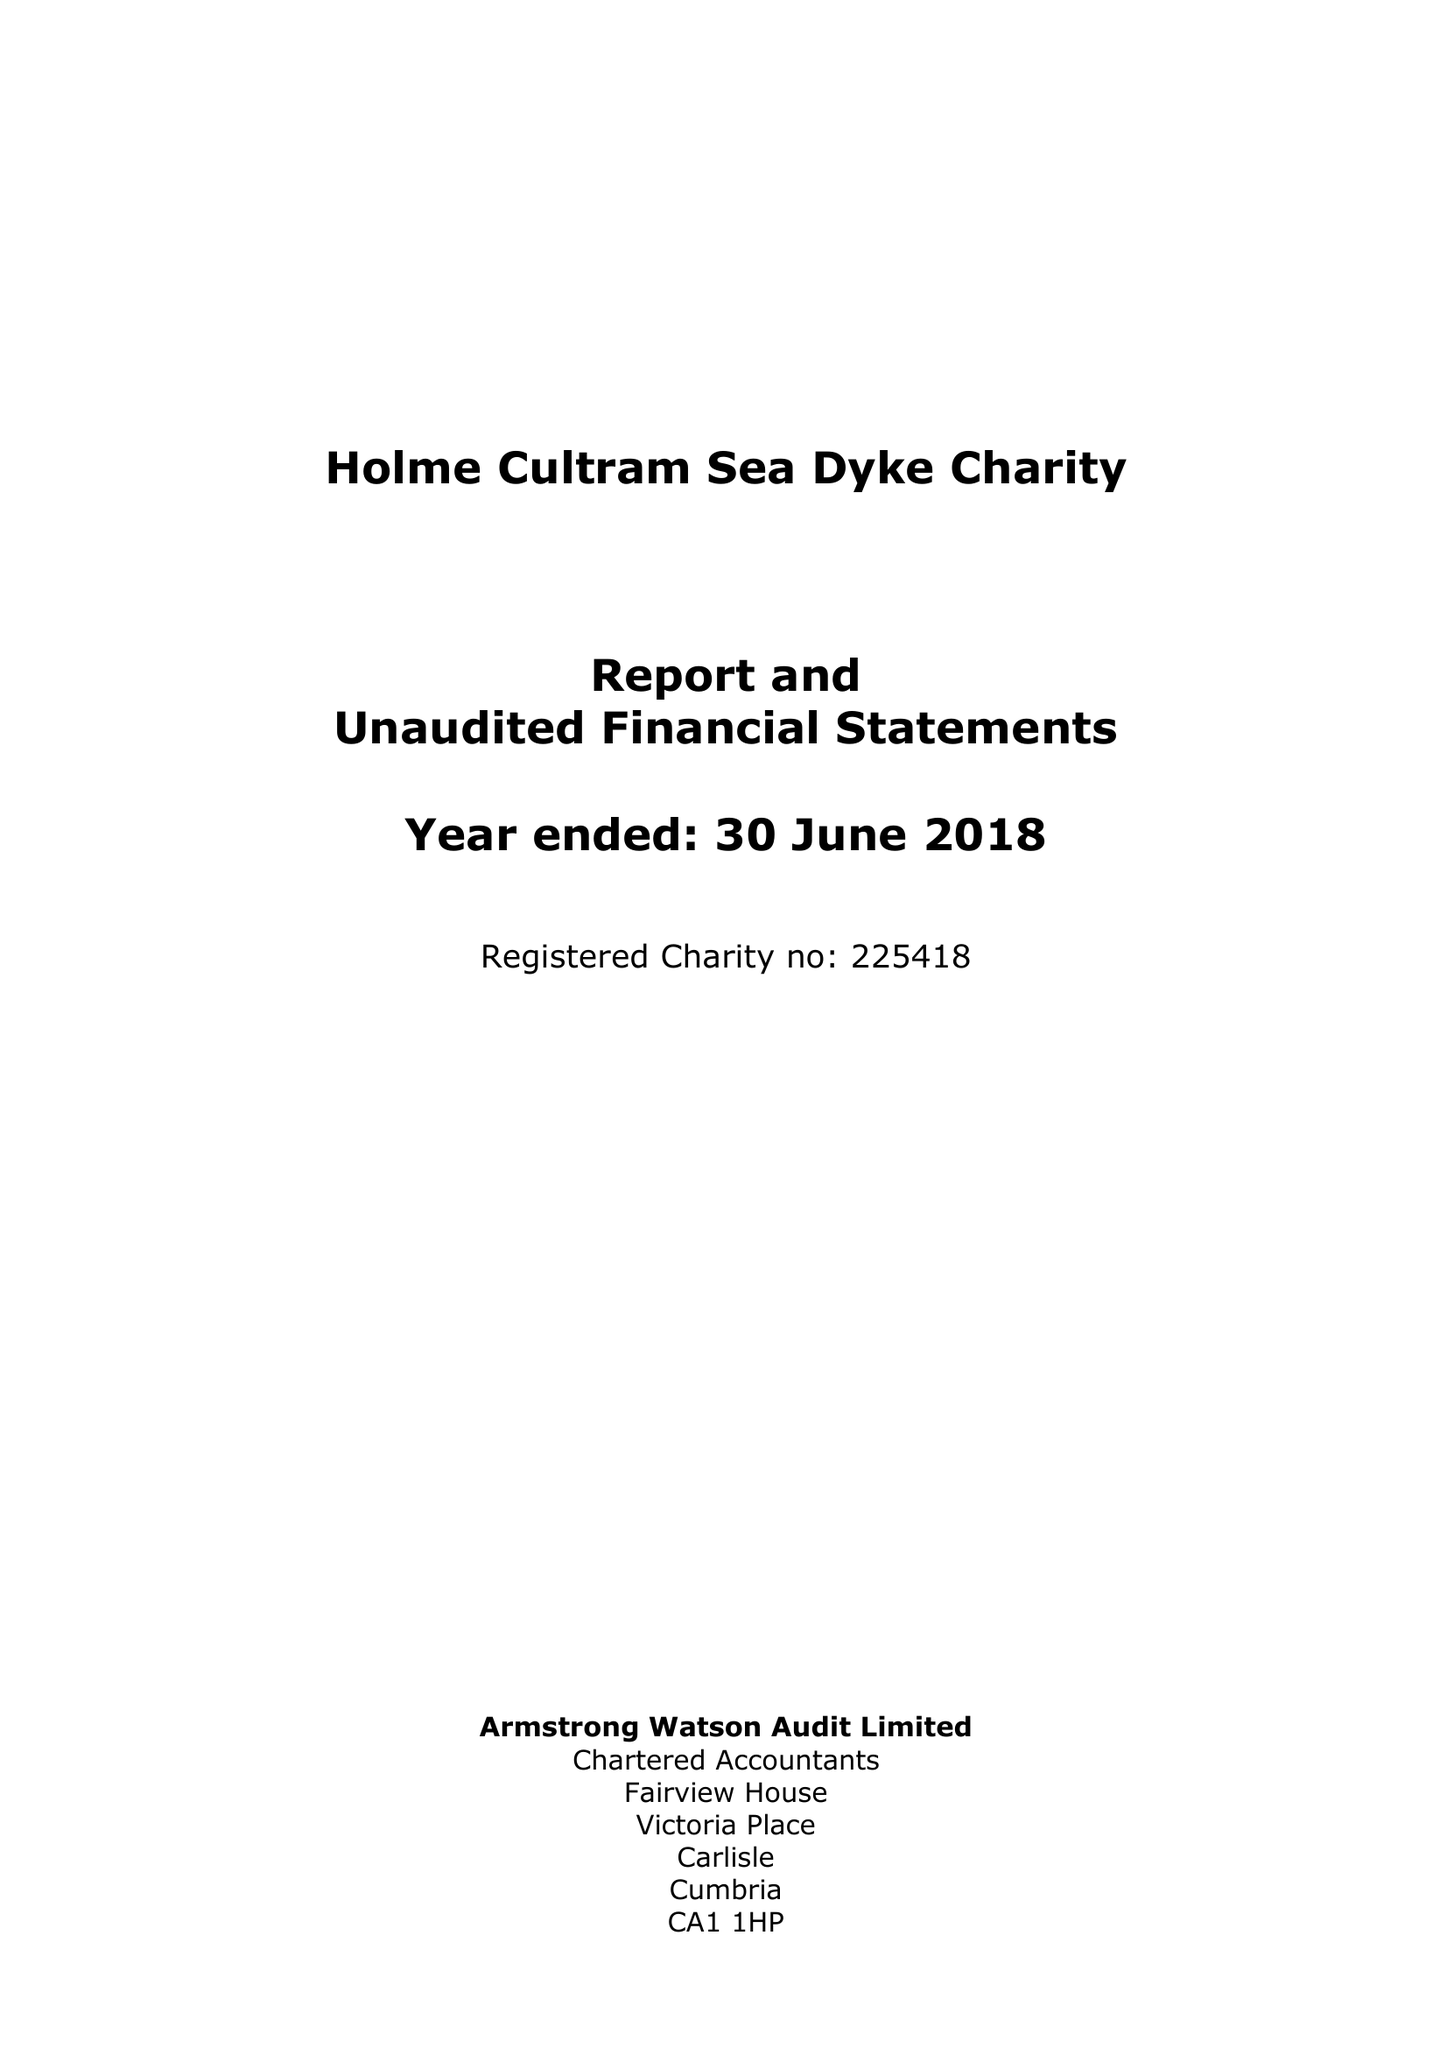What is the value for the address__postcode?
Answer the question using a single word or phrase. CA7 4PT 